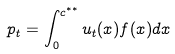<formula> <loc_0><loc_0><loc_500><loc_500>p _ { t } = \int _ { 0 } ^ { c ^ { * * } } u _ { t } ( x ) f ( x ) d x</formula> 